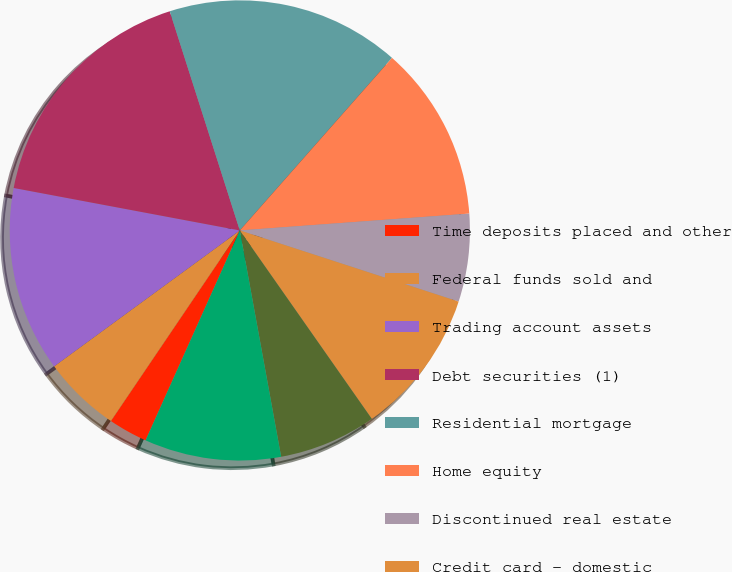<chart> <loc_0><loc_0><loc_500><loc_500><pie_chart><fcel>Time deposits placed and other<fcel>Federal funds sold and<fcel>Trading account assets<fcel>Debt securities (1)<fcel>Residential mortgage<fcel>Home equity<fcel>Discontinued real estate<fcel>Credit card - domestic<fcel>Credit card - foreign<fcel>Direct/Indirect consumer (3)<nl><fcel>2.75%<fcel>5.48%<fcel>13.01%<fcel>17.12%<fcel>16.43%<fcel>12.33%<fcel>6.17%<fcel>10.27%<fcel>6.85%<fcel>9.59%<nl></chart> 